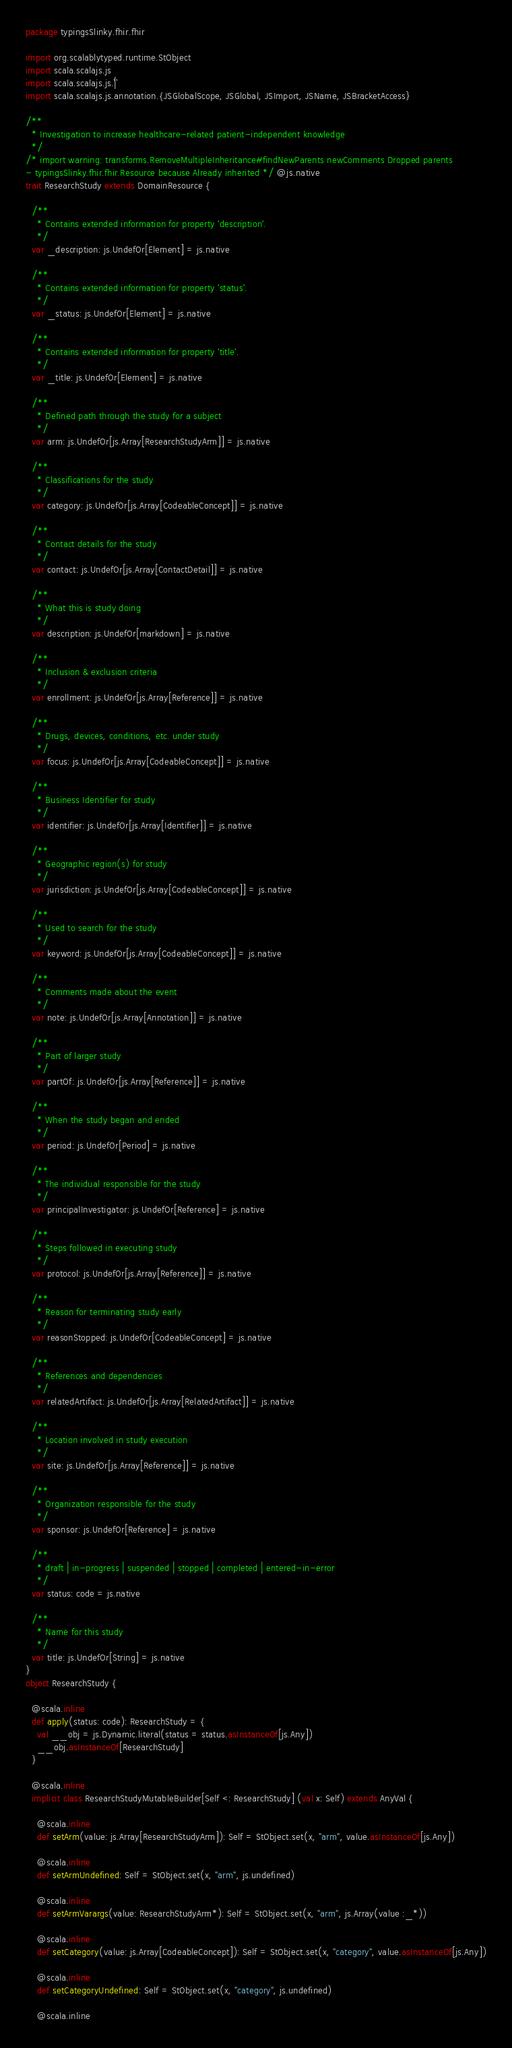Convert code to text. <code><loc_0><loc_0><loc_500><loc_500><_Scala_>package typingsSlinky.fhir.fhir

import org.scalablytyped.runtime.StObject
import scala.scalajs.js
import scala.scalajs.js.`|`
import scala.scalajs.js.annotation.{JSGlobalScope, JSGlobal, JSImport, JSName, JSBracketAccess}

/**
  * Investigation to increase healthcare-related patient-independent knowledge
  */
/* import warning: transforms.RemoveMultipleInheritance#findNewParents newComments Dropped parents 
- typingsSlinky.fhir.fhir.Resource because Already inherited */ @js.native
trait ResearchStudy extends DomainResource {
  
  /**
    * Contains extended information for property 'description'.
    */
  var _description: js.UndefOr[Element] = js.native
  
  /**
    * Contains extended information for property 'status'.
    */
  var _status: js.UndefOr[Element] = js.native
  
  /**
    * Contains extended information for property 'title'.
    */
  var _title: js.UndefOr[Element] = js.native
  
  /**
    * Defined path through the study for a subject
    */
  var arm: js.UndefOr[js.Array[ResearchStudyArm]] = js.native
  
  /**
    * Classifications for the study
    */
  var category: js.UndefOr[js.Array[CodeableConcept]] = js.native
  
  /**
    * Contact details for the study
    */
  var contact: js.UndefOr[js.Array[ContactDetail]] = js.native
  
  /**
    * What this is study doing
    */
  var description: js.UndefOr[markdown] = js.native
  
  /**
    * Inclusion & exclusion criteria
    */
  var enrollment: js.UndefOr[js.Array[Reference]] = js.native
  
  /**
    * Drugs, devices, conditions, etc. under study
    */
  var focus: js.UndefOr[js.Array[CodeableConcept]] = js.native
  
  /**
    * Business Identifier for study
    */
  var identifier: js.UndefOr[js.Array[Identifier]] = js.native
  
  /**
    * Geographic region(s) for study
    */
  var jurisdiction: js.UndefOr[js.Array[CodeableConcept]] = js.native
  
  /**
    * Used to search for the study
    */
  var keyword: js.UndefOr[js.Array[CodeableConcept]] = js.native
  
  /**
    * Comments made about the event
    */
  var note: js.UndefOr[js.Array[Annotation]] = js.native
  
  /**
    * Part of larger study
    */
  var partOf: js.UndefOr[js.Array[Reference]] = js.native
  
  /**
    * When the study began and ended
    */
  var period: js.UndefOr[Period] = js.native
  
  /**
    * The individual responsible for the study
    */
  var principalInvestigator: js.UndefOr[Reference] = js.native
  
  /**
    * Steps followed in executing study
    */
  var protocol: js.UndefOr[js.Array[Reference]] = js.native
  
  /**
    * Reason for terminating study early
    */
  var reasonStopped: js.UndefOr[CodeableConcept] = js.native
  
  /**
    * References and dependencies
    */
  var relatedArtifact: js.UndefOr[js.Array[RelatedArtifact]] = js.native
  
  /**
    * Location involved in study execution
    */
  var site: js.UndefOr[js.Array[Reference]] = js.native
  
  /**
    * Organization responsible for the study
    */
  var sponsor: js.UndefOr[Reference] = js.native
  
  /**
    * draft | in-progress | suspended | stopped | completed | entered-in-error
    */
  var status: code = js.native
  
  /**
    * Name for this study
    */
  var title: js.UndefOr[String] = js.native
}
object ResearchStudy {
  
  @scala.inline
  def apply(status: code): ResearchStudy = {
    val __obj = js.Dynamic.literal(status = status.asInstanceOf[js.Any])
    __obj.asInstanceOf[ResearchStudy]
  }
  
  @scala.inline
  implicit class ResearchStudyMutableBuilder[Self <: ResearchStudy] (val x: Self) extends AnyVal {
    
    @scala.inline
    def setArm(value: js.Array[ResearchStudyArm]): Self = StObject.set(x, "arm", value.asInstanceOf[js.Any])
    
    @scala.inline
    def setArmUndefined: Self = StObject.set(x, "arm", js.undefined)
    
    @scala.inline
    def setArmVarargs(value: ResearchStudyArm*): Self = StObject.set(x, "arm", js.Array(value :_*))
    
    @scala.inline
    def setCategory(value: js.Array[CodeableConcept]): Self = StObject.set(x, "category", value.asInstanceOf[js.Any])
    
    @scala.inline
    def setCategoryUndefined: Self = StObject.set(x, "category", js.undefined)
    
    @scala.inline</code> 